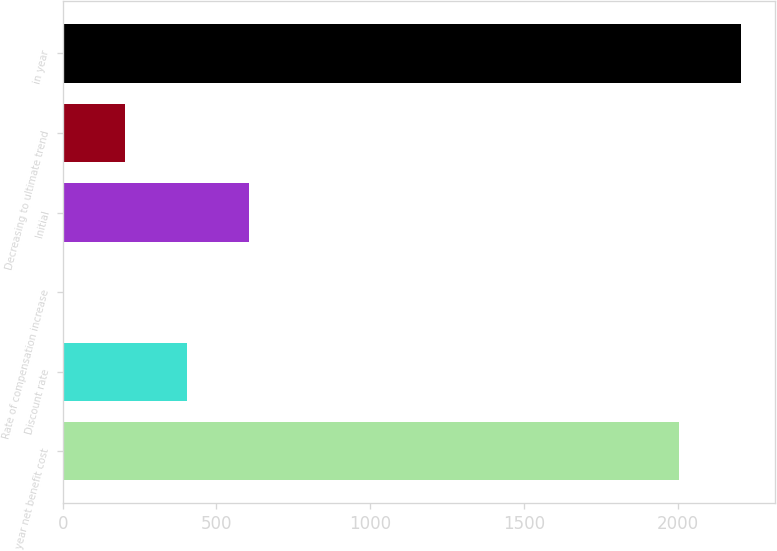Convert chart. <chart><loc_0><loc_0><loc_500><loc_500><bar_chart><fcel>year net benefit cost<fcel>Discount rate<fcel>Rate of compensation increase<fcel>Initial<fcel>Decreasing to ultimate trend<fcel>in year<nl><fcel>2005<fcel>404.81<fcel>3.75<fcel>605.34<fcel>204.28<fcel>2205.53<nl></chart> 